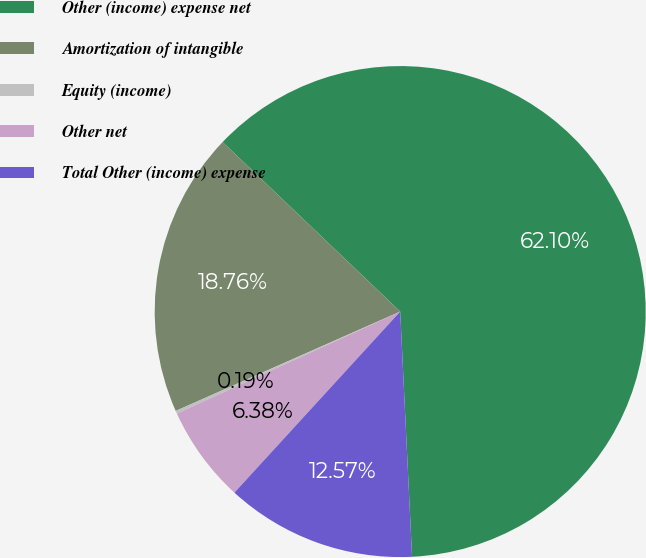Convert chart. <chart><loc_0><loc_0><loc_500><loc_500><pie_chart><fcel>Other (income) expense net<fcel>Amortization of intangible<fcel>Equity (income)<fcel>Other net<fcel>Total Other (income) expense<nl><fcel>62.11%<fcel>18.76%<fcel>0.19%<fcel>6.38%<fcel>12.57%<nl></chart> 